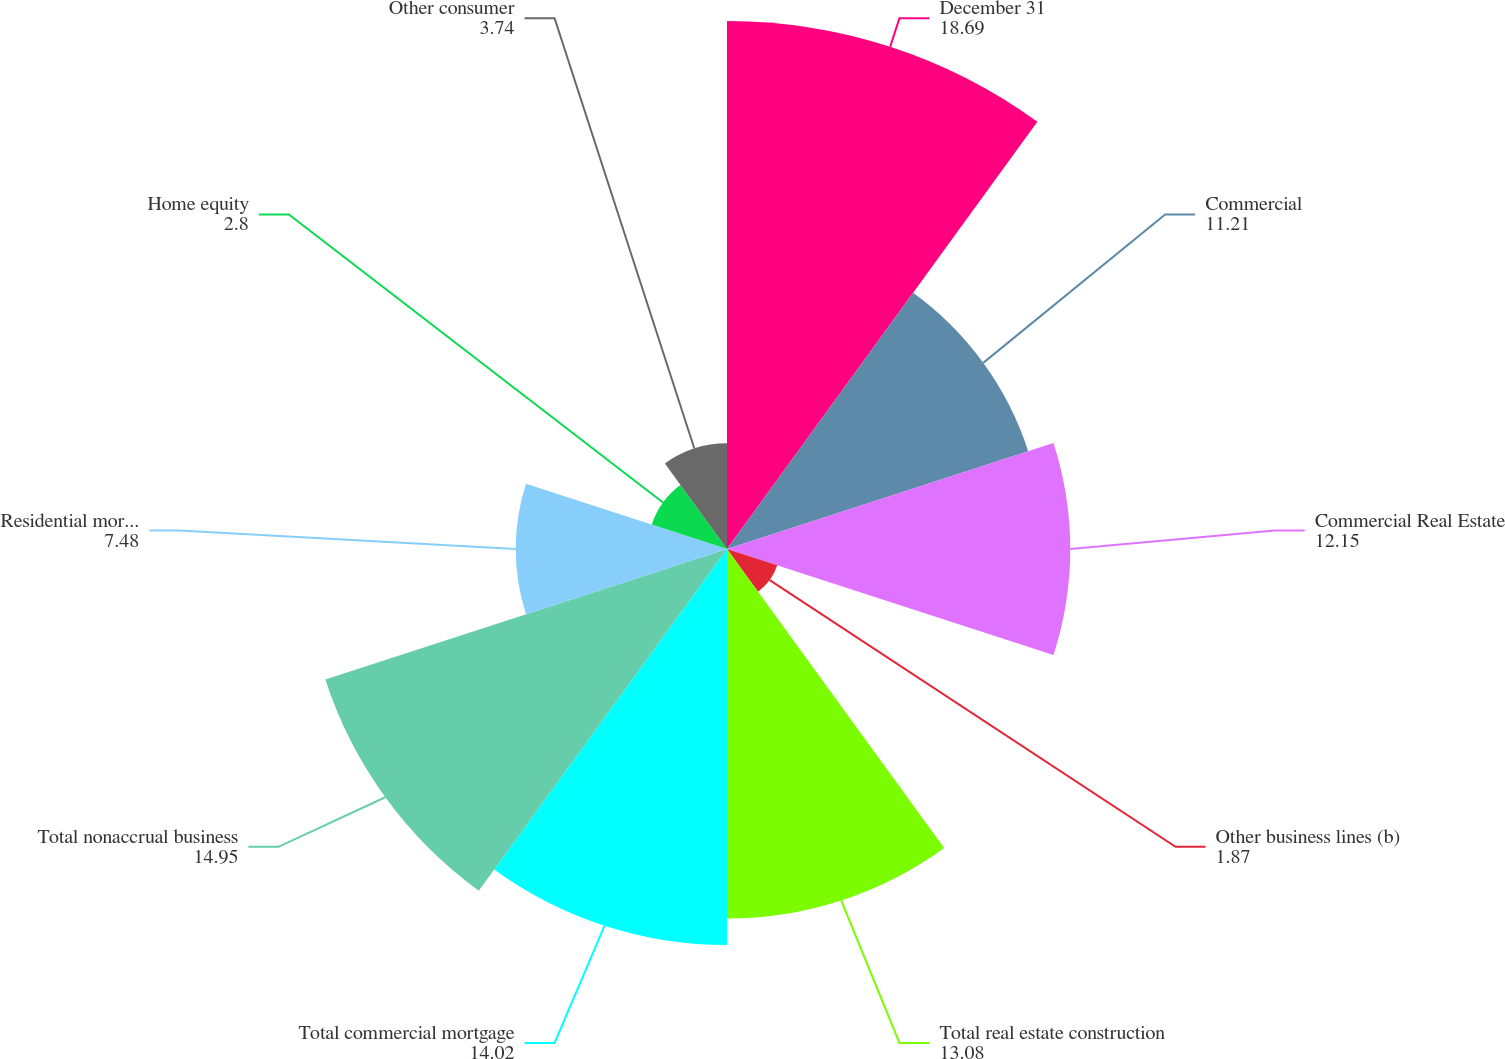<chart> <loc_0><loc_0><loc_500><loc_500><pie_chart><fcel>December 31<fcel>Commercial<fcel>Commercial Real Estate<fcel>Other business lines (b)<fcel>Total real estate construction<fcel>Total commercial mortgage<fcel>Total nonaccrual business<fcel>Residential mortgage<fcel>Home equity<fcel>Other consumer<nl><fcel>18.69%<fcel>11.21%<fcel>12.15%<fcel>1.87%<fcel>13.08%<fcel>14.02%<fcel>14.95%<fcel>7.48%<fcel>2.8%<fcel>3.74%<nl></chart> 